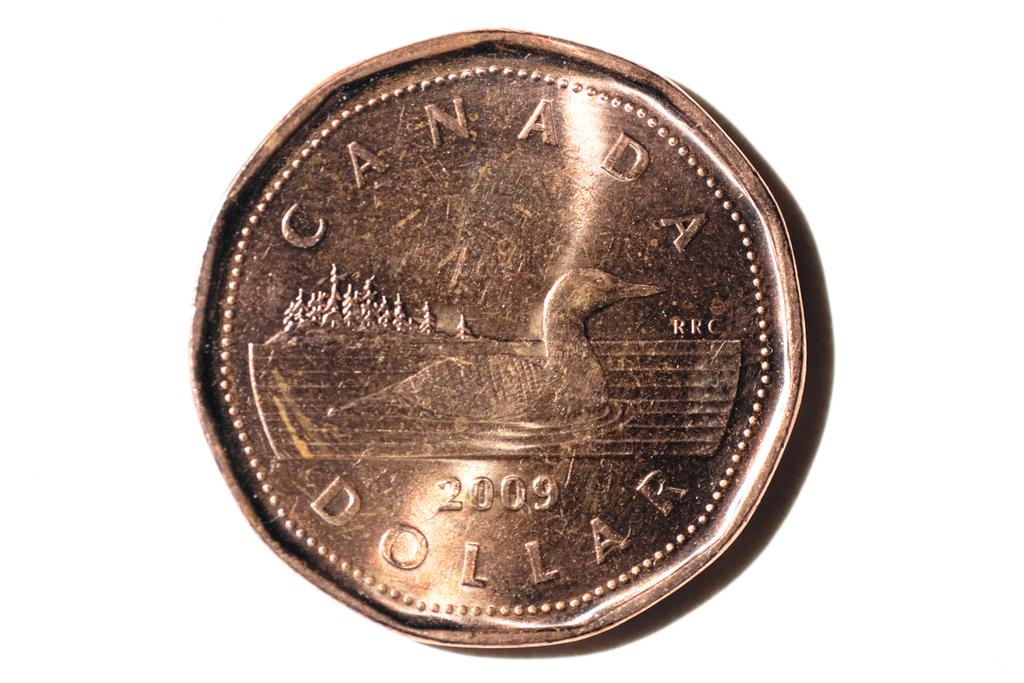Provide a one-sentence caption for the provided image. The Canada Dollar will one day be considered a collectible. 